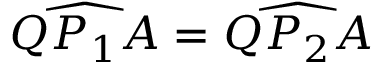<formula> <loc_0><loc_0><loc_500><loc_500>{ \widehat { Q P _ { 1 } A } } = { \widehat { Q P _ { 2 } A } }</formula> 